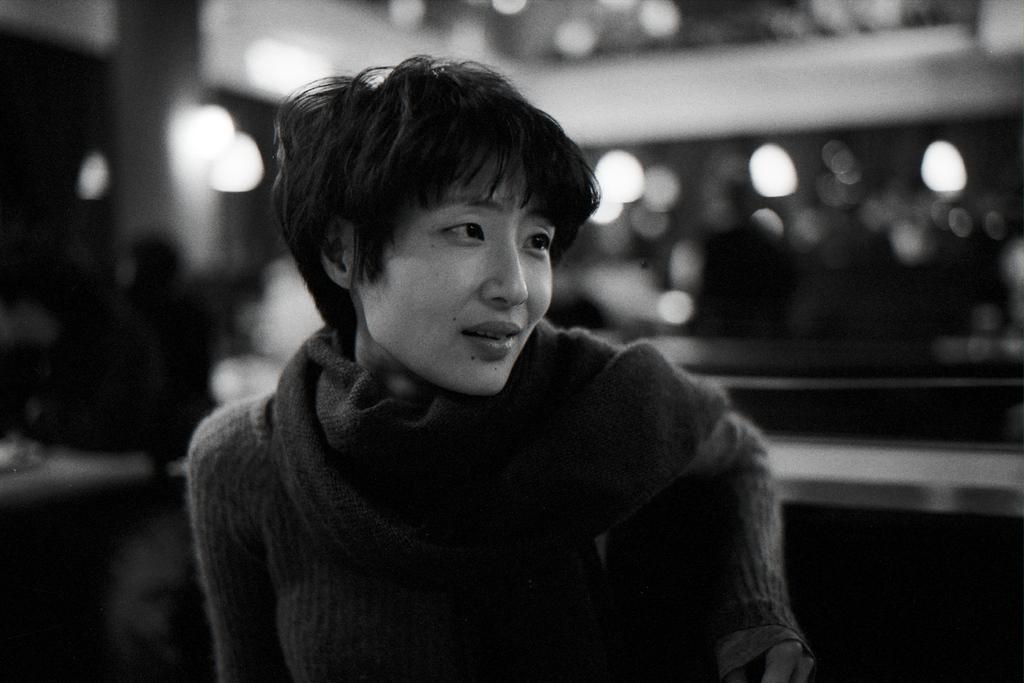Please provide a concise description of this image. This is a black and white pic. Here we can see a woman. In the background the image is blur but we can see wall,lights and there are few persons and some other objects. 